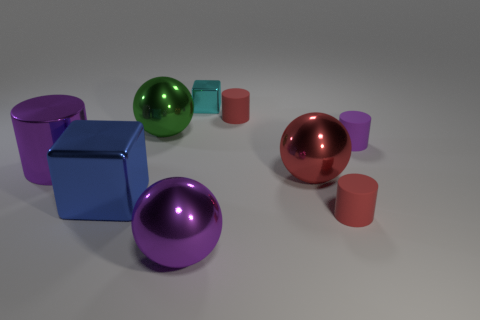Are there the same number of cylinders that are on the left side of the large blue metallic thing and big metal spheres in front of the big red metallic ball?
Provide a short and direct response. Yes. What number of other things are there of the same material as the big green ball
Give a very brief answer. 5. Are there an equal number of tiny metallic cubes in front of the small metal object and green metal spheres?
Your answer should be compact. No. Is the size of the cyan metallic cube the same as the metal cylinder that is left of the big green object?
Give a very brief answer. No. What shape is the big purple metallic thing to the left of the big green metal thing?
Ensure brevity in your answer.  Cylinder. Are there any other things that are the same shape as the large green thing?
Make the answer very short. Yes. Are any tiny red shiny things visible?
Ensure brevity in your answer.  No. Do the matte cylinder that is in front of the purple matte cylinder and the block that is in front of the green ball have the same size?
Offer a very short reply. No. What material is the purple object that is behind the large shiny cube and on the right side of the large cylinder?
Make the answer very short. Rubber. There is a green object; what number of purple metallic cylinders are behind it?
Give a very brief answer. 0. 